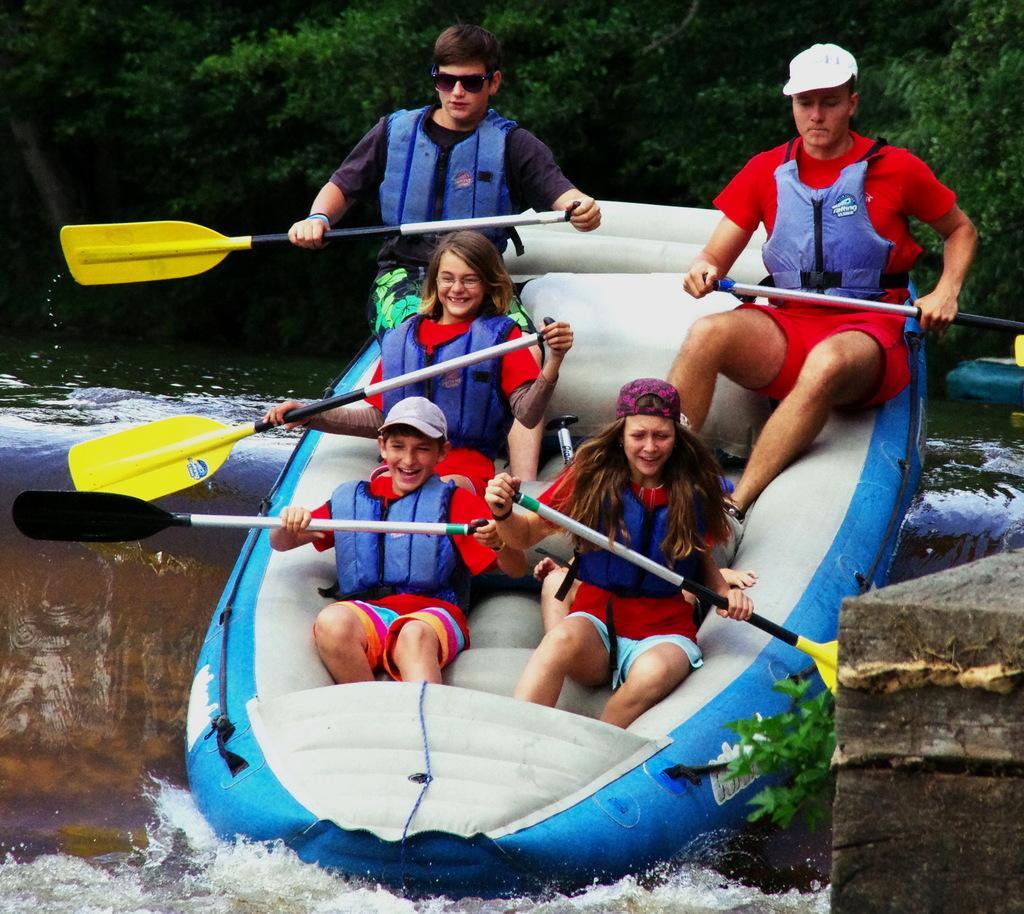Can you describe this image briefly? In this image we can see few persons are rafting on the water and all of them are holding paddles in their hands. In the background we can see water and trees. 